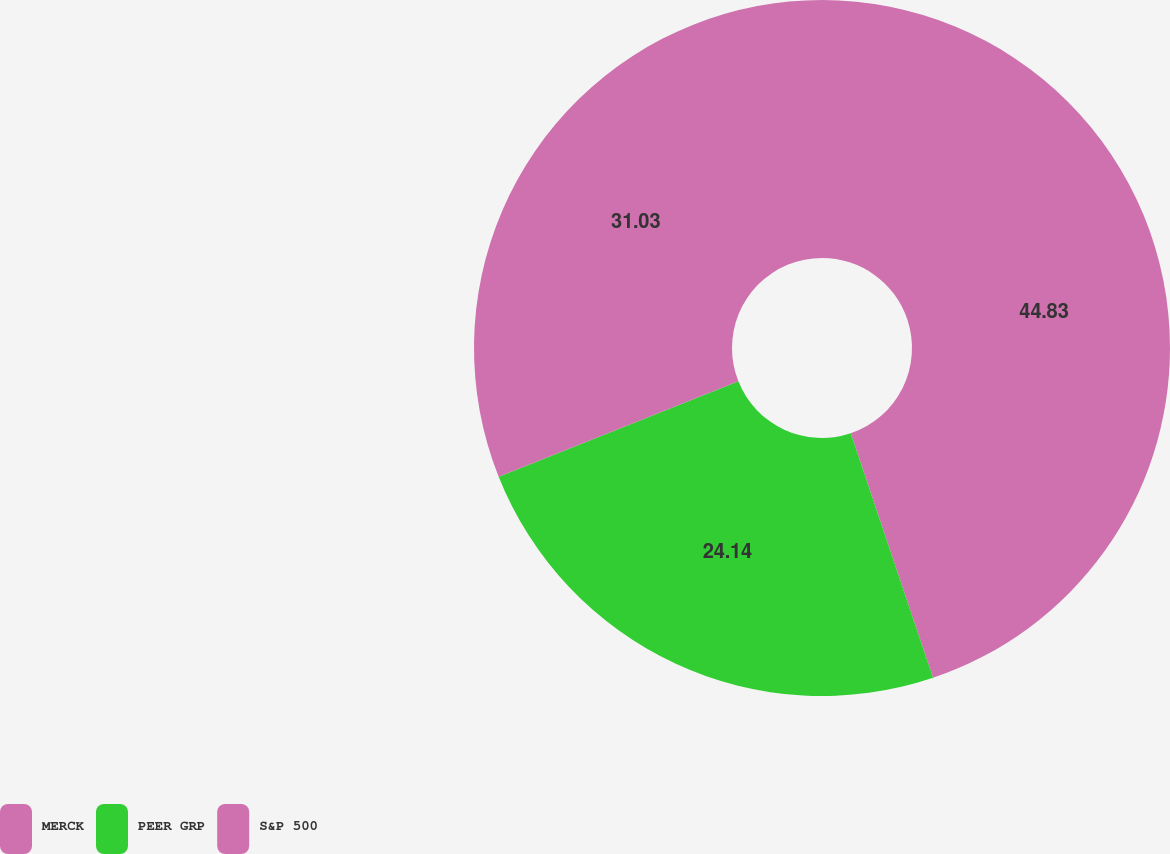<chart> <loc_0><loc_0><loc_500><loc_500><pie_chart><fcel>MERCK<fcel>PEER GRP<fcel>S&P 500<nl><fcel>44.83%<fcel>24.14%<fcel>31.03%<nl></chart> 